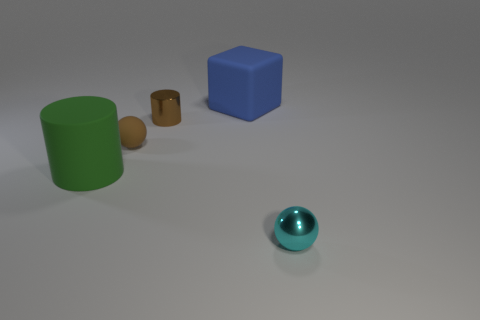Add 1 small gray objects. How many objects exist? 6 Subtract all cylinders. How many objects are left? 3 Add 3 large blue matte things. How many large blue matte things are left? 4 Add 3 big cylinders. How many big cylinders exist? 4 Subtract 1 brown balls. How many objects are left? 4 Subtract all big green matte objects. Subtract all small brown shiny objects. How many objects are left? 3 